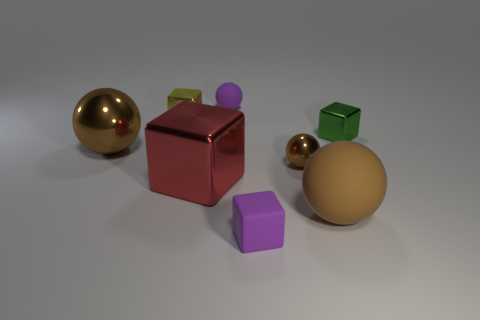Are there any tiny purple blocks in front of the matte ball that is in front of the big shiny object that is on the right side of the tiny yellow block?
Your response must be concise. Yes. What number of things are either rubber balls behind the big brown rubber sphere or metal blocks behind the red cube?
Your response must be concise. 3. Does the thing that is left of the tiny yellow thing have the same material as the tiny yellow cube?
Provide a short and direct response. Yes. There is a sphere that is behind the small brown object and to the right of the large brown metallic object; what is it made of?
Your answer should be compact. Rubber. There is a tiny object that is in front of the matte sphere in front of the tiny brown shiny thing; what color is it?
Keep it short and to the point. Purple. There is a purple object that is the same shape as the brown rubber object; what is its material?
Your response must be concise. Rubber. There is a big ball to the right of the rubber thing that is behind the brown object on the left side of the yellow metallic object; what is its color?
Give a very brief answer. Brown. How many objects are either large metallic blocks or small metal cubes?
Offer a very short reply. 3. How many brown shiny things are the same shape as the big brown matte thing?
Offer a terse response. 2. Does the red block have the same material as the big brown object in front of the big shiny ball?
Provide a succinct answer. No. 